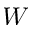Convert formula to latex. <formula><loc_0><loc_0><loc_500><loc_500>W</formula> 